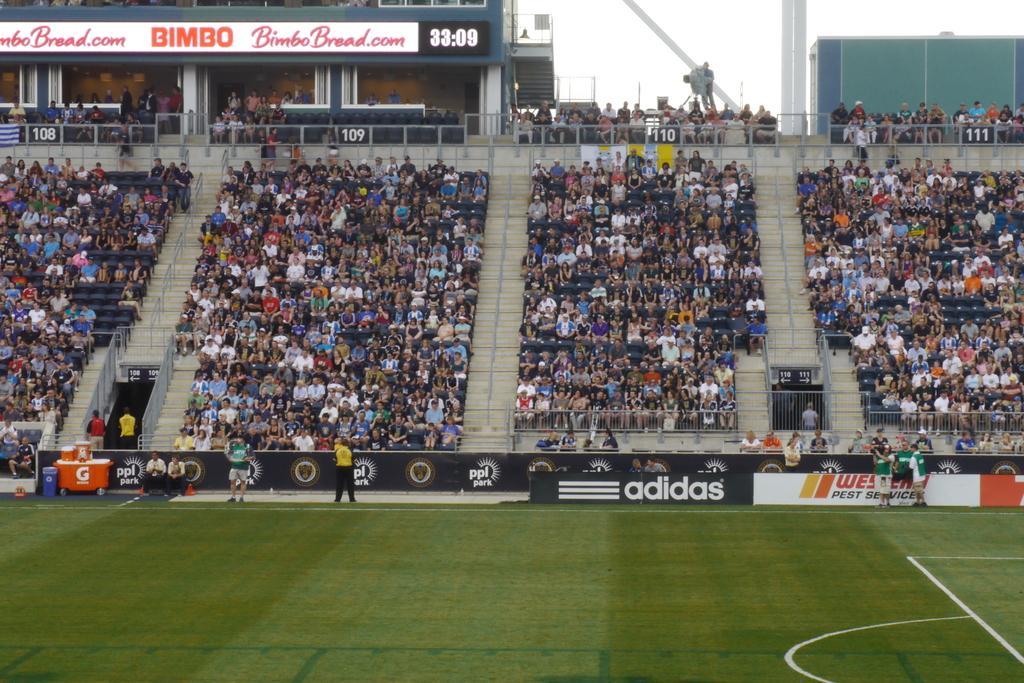How would you summarize this image in a sentence or two? In the image we can see there are many audiences sitting and wearing clothes. We can even see the poster, stairs and the sky. Here we can see the ground and on the ground there are people wearing clothes and shoes. 